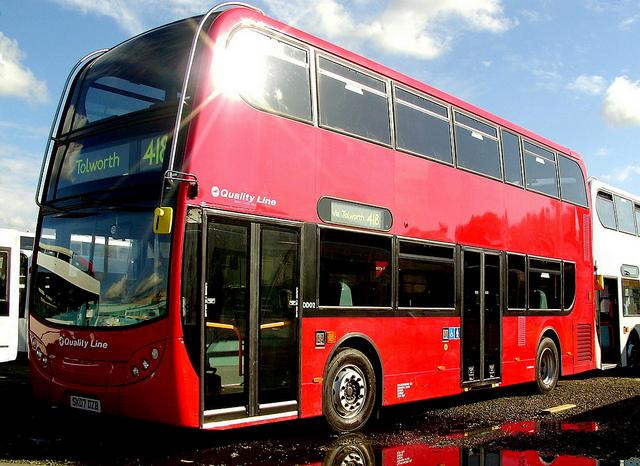How many levels of seating is on this bus?
Quick response, please. 2. What color is the bus?
Keep it brief. Red. Are the doors open on any of the the buses?
Answer briefly. Yes. 